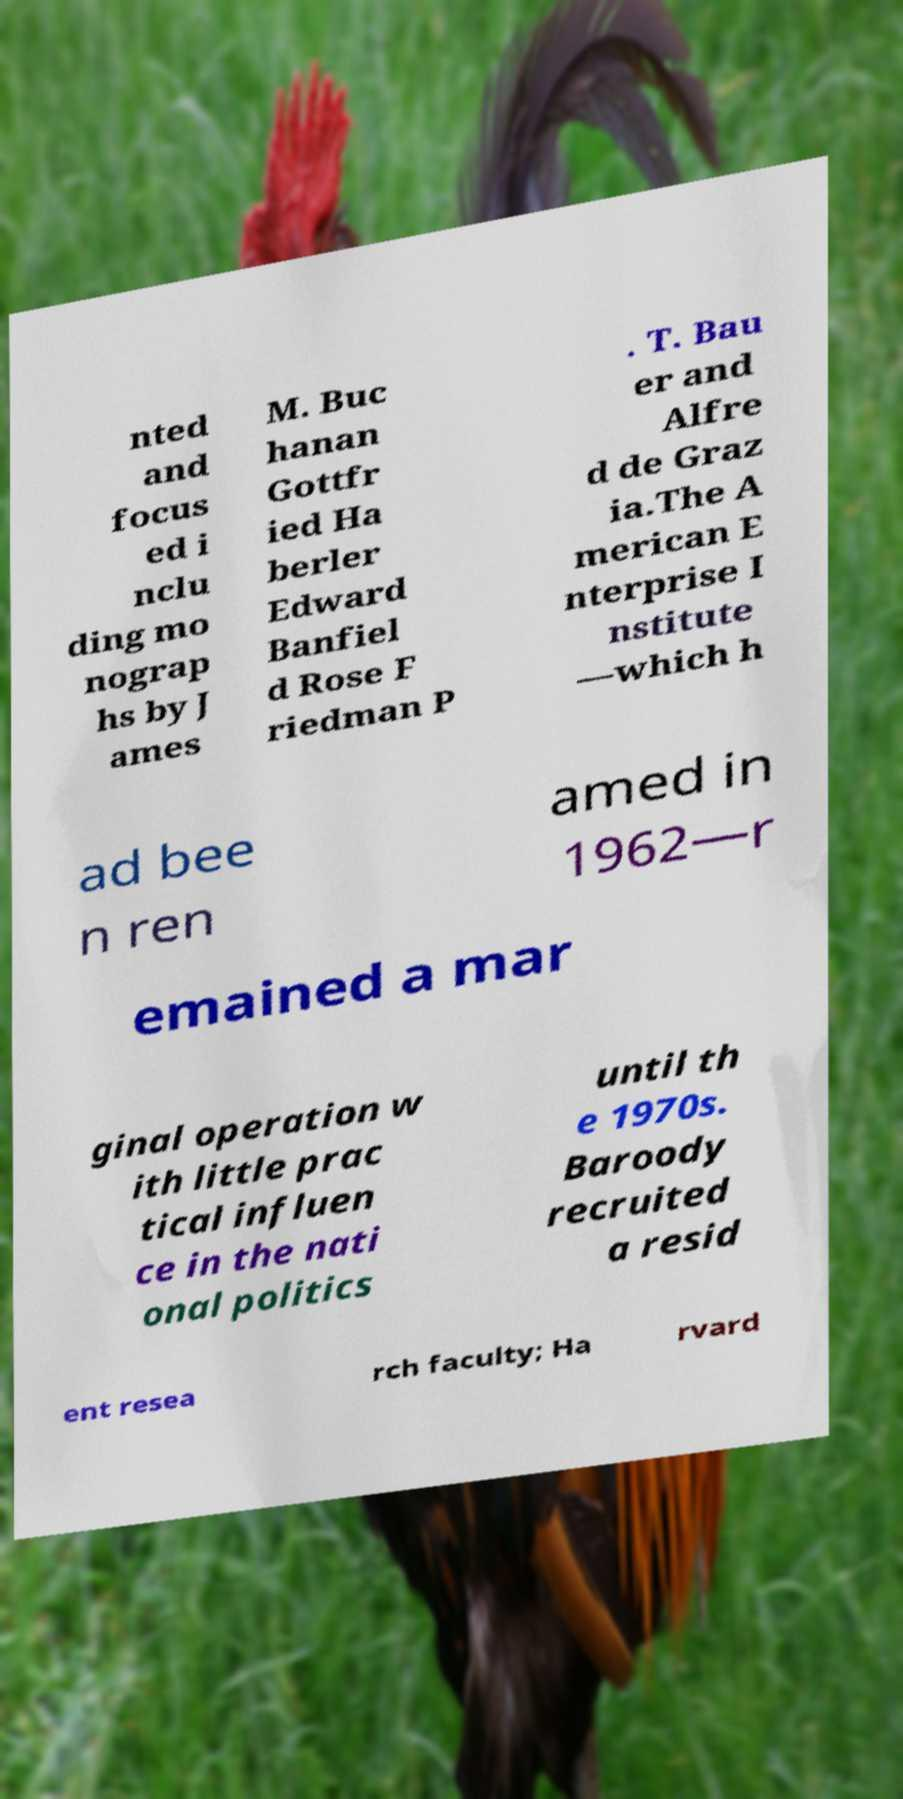Can you accurately transcribe the text from the provided image for me? nted and focus ed i nclu ding mo nograp hs by J ames M. Buc hanan Gottfr ied Ha berler Edward Banfiel d Rose F riedman P . T. Bau er and Alfre d de Graz ia.The A merican E nterprise I nstitute —which h ad bee n ren amed in 1962—r emained a mar ginal operation w ith little prac tical influen ce in the nati onal politics until th e 1970s. Baroody recruited a resid ent resea rch faculty; Ha rvard 